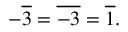Convert formula to latex. <formula><loc_0><loc_0><loc_500><loc_500>- { \overline { 3 } } = { \overline { - 3 } } = { \overline { 1 } } .</formula> 